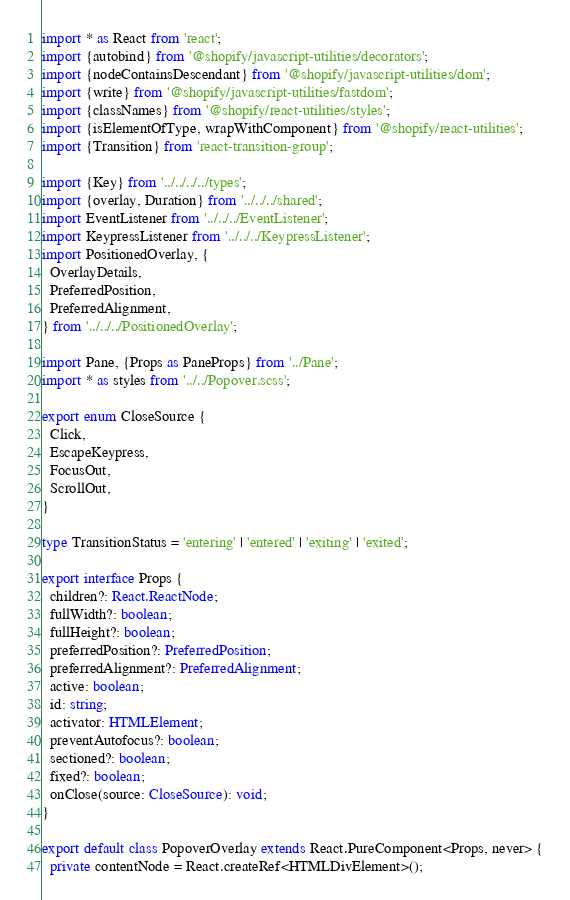Convert code to text. <code><loc_0><loc_0><loc_500><loc_500><_TypeScript_>import * as React from 'react';
import {autobind} from '@shopify/javascript-utilities/decorators';
import {nodeContainsDescendant} from '@shopify/javascript-utilities/dom';
import {write} from '@shopify/javascript-utilities/fastdom';
import {classNames} from '@shopify/react-utilities/styles';
import {isElementOfType, wrapWithComponent} from '@shopify/react-utilities';
import {Transition} from 'react-transition-group';

import {Key} from '../../../../types';
import {overlay, Duration} from '../../../shared';
import EventListener from '../../../EventListener';
import KeypressListener from '../../../KeypressListener';
import PositionedOverlay, {
  OverlayDetails,
  PreferredPosition,
  PreferredAlignment,
} from '../../../PositionedOverlay';

import Pane, {Props as PaneProps} from '../Pane';
import * as styles from '../../Popover.scss';

export enum CloseSource {
  Click,
  EscapeKeypress,
  FocusOut,
  ScrollOut,
}

type TransitionStatus = 'entering' | 'entered' | 'exiting' | 'exited';

export interface Props {
  children?: React.ReactNode;
  fullWidth?: boolean;
  fullHeight?: boolean;
  preferredPosition?: PreferredPosition;
  preferredAlignment?: PreferredAlignment;
  active: boolean;
  id: string;
  activator: HTMLElement;
  preventAutofocus?: boolean;
  sectioned?: boolean;
  fixed?: boolean;
  onClose(source: CloseSource): void;
}

export default class PopoverOverlay extends React.PureComponent<Props, never> {
  private contentNode = React.createRef<HTMLDivElement>();</code> 